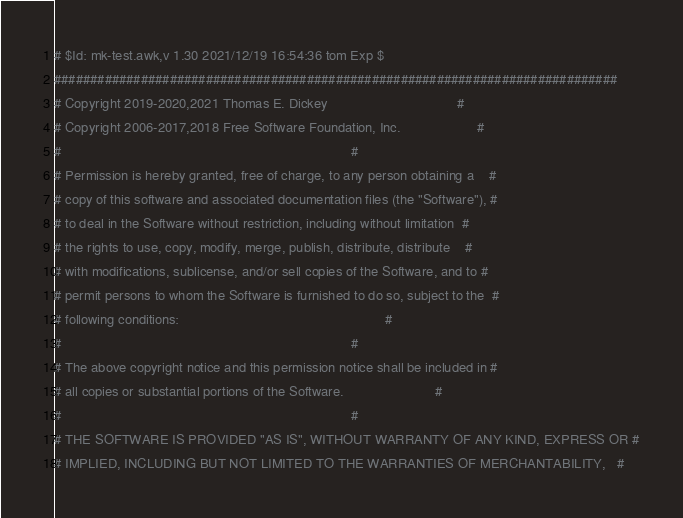Convert code to text. <code><loc_0><loc_0><loc_500><loc_500><_Awk_># $Id: mk-test.awk,v 1.30 2021/12/19 16:54:36 tom Exp $
##############################################################################
# Copyright 2019-2020,2021 Thomas E. Dickey                                  #
# Copyright 2006-2017,2018 Free Software Foundation, Inc.                    #
#                                                                            #
# Permission is hereby granted, free of charge, to any person obtaining a    #
# copy of this software and associated documentation files (the "Software"), #
# to deal in the Software without restriction, including without limitation  #
# the rights to use, copy, modify, merge, publish, distribute, distribute    #
# with modifications, sublicense, and/or sell copies of the Software, and to #
# permit persons to whom the Software is furnished to do so, subject to the  #
# following conditions:                                                      #
#                                                                            #
# The above copyright notice and this permission notice shall be included in #
# all copies or substantial portions of the Software.                        #
#                                                                            #
# THE SOFTWARE IS PROVIDED "AS IS", WITHOUT WARRANTY OF ANY KIND, EXPRESS OR #
# IMPLIED, INCLUDING BUT NOT LIMITED TO THE WARRANTIES OF MERCHANTABILITY,   #</code> 